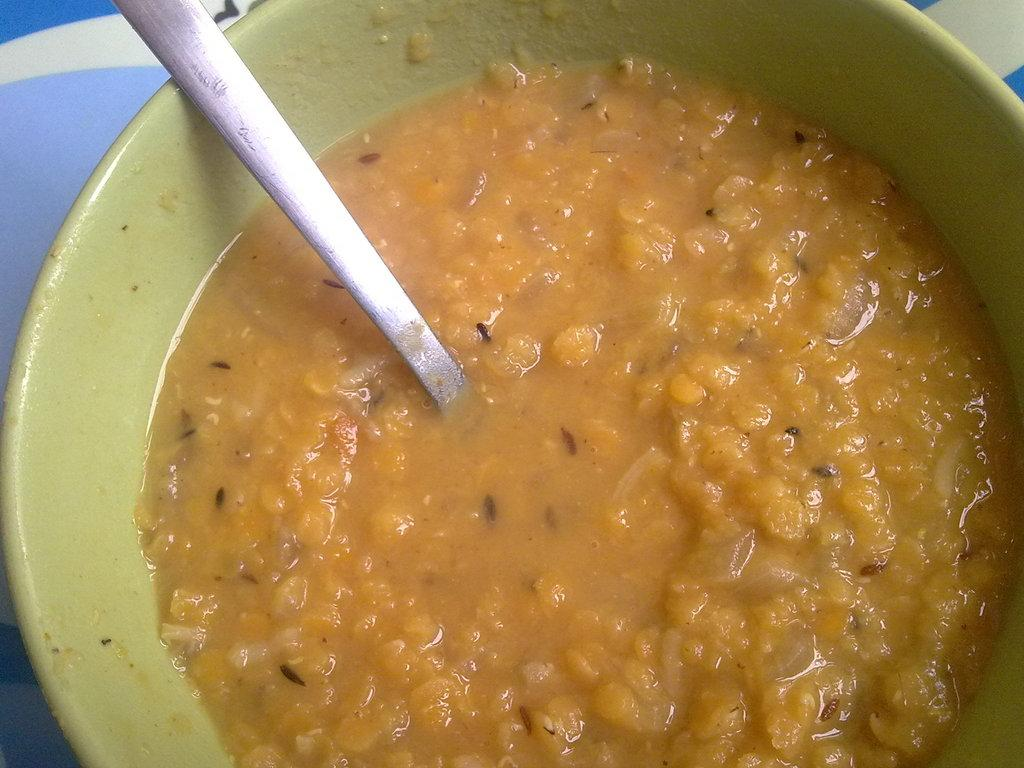What type of food can be seen in the image? There is not specified in the facts provided. What utensil is present in the image? There is a spoon in the image. What is the food contained in? There is a bowl in the image. Where is the bowl placed? The bowl is placed on a surface. How many frogs are sitting on the sun in the image? There is no sun or frogs present in the image. 